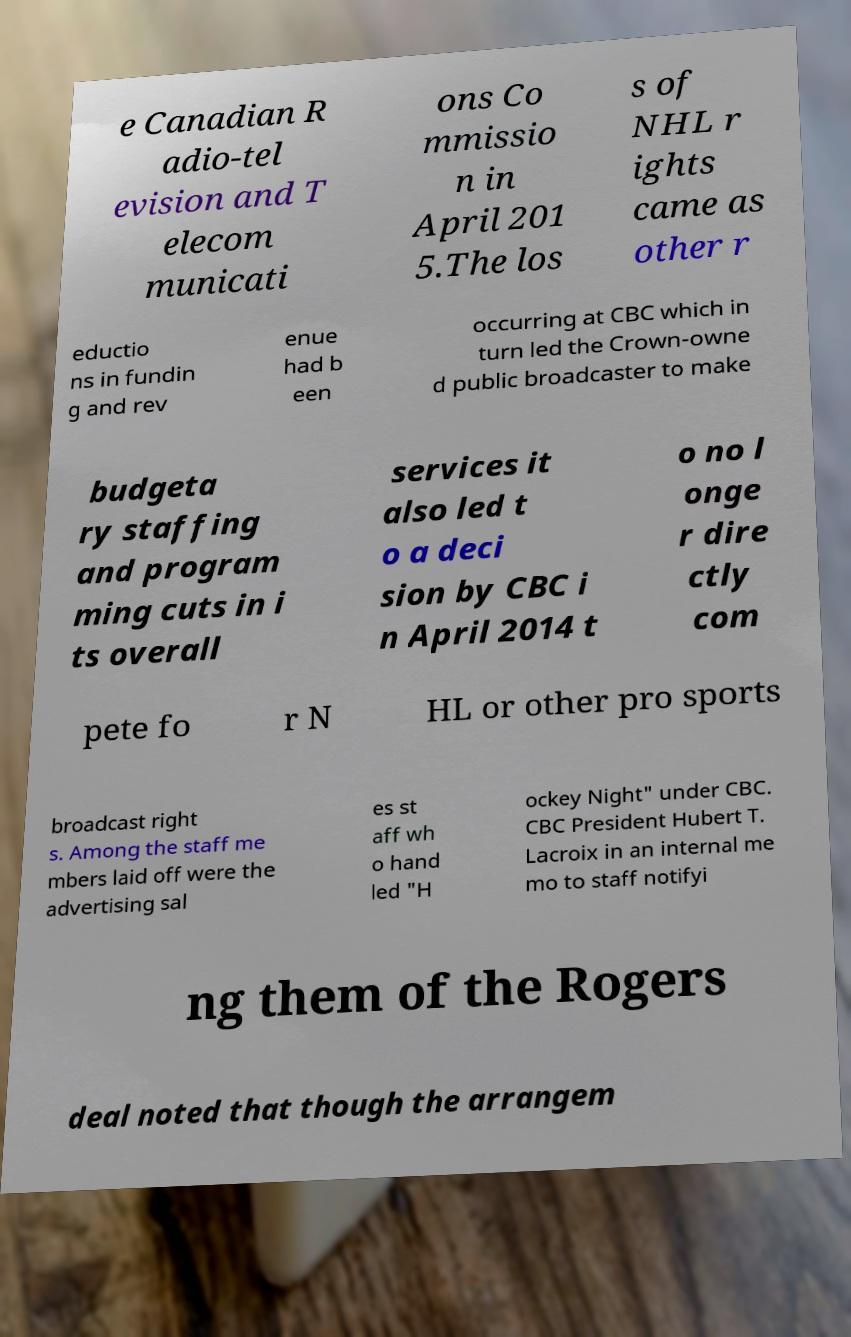Can you read and provide the text displayed in the image?This photo seems to have some interesting text. Can you extract and type it out for me? e Canadian R adio-tel evision and T elecom municati ons Co mmissio n in April 201 5.The los s of NHL r ights came as other r eductio ns in fundin g and rev enue had b een occurring at CBC which in turn led the Crown-owne d public broadcaster to make budgeta ry staffing and program ming cuts in i ts overall services it also led t o a deci sion by CBC i n April 2014 t o no l onge r dire ctly com pete fo r N HL or other pro sports broadcast right s. Among the staff me mbers laid off were the advertising sal es st aff wh o hand led "H ockey Night" under CBC. CBC President Hubert T. Lacroix in an internal me mo to staff notifyi ng them of the Rogers deal noted that though the arrangem 